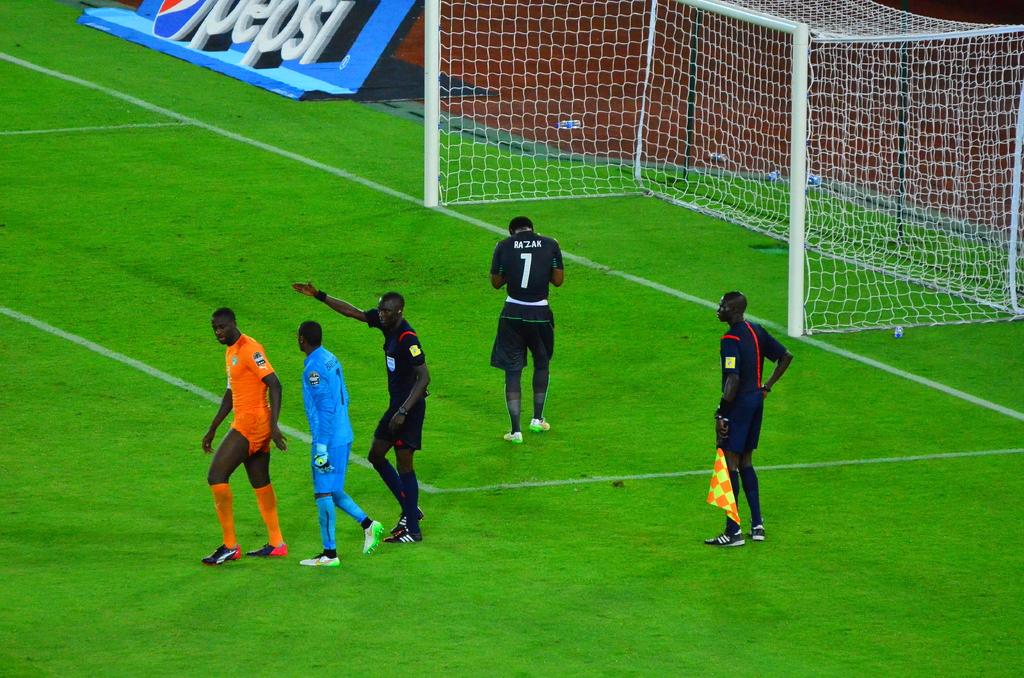What number is the man walking away from the camera?
Keep it short and to the point. 1. 